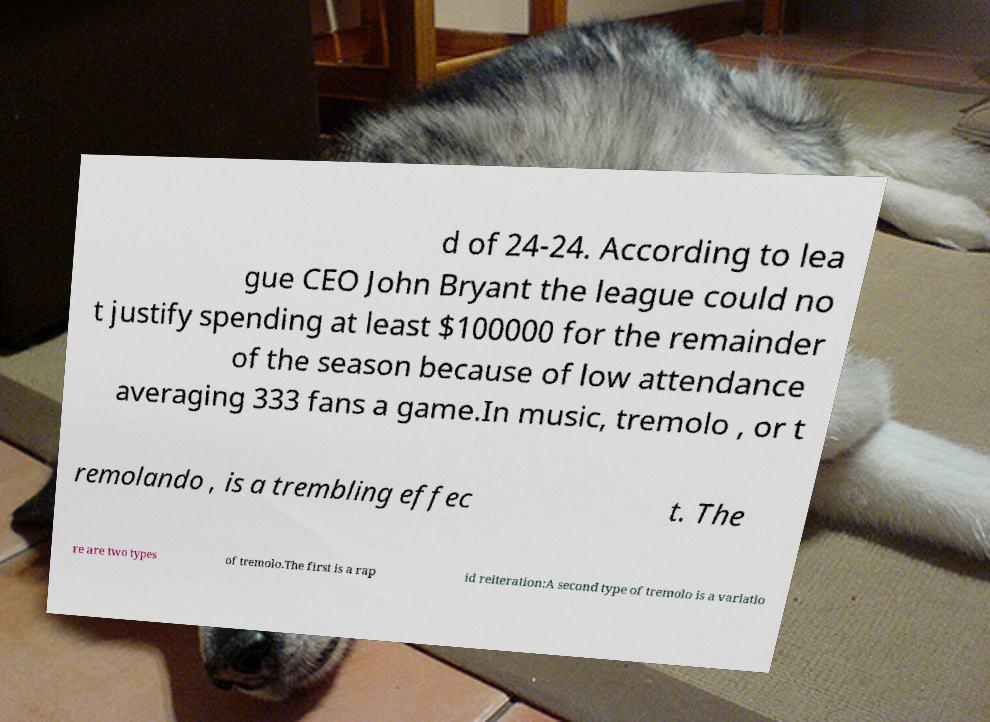Could you extract and type out the text from this image? d of 24-24. According to lea gue CEO John Bryant the league could no t justify spending at least $100000 for the remainder of the season because of low attendance averaging 333 fans a game.In music, tremolo , or t remolando , is a trembling effec t. The re are two types of tremolo.The first is a rap id reiteration:A second type of tremolo is a variatio 